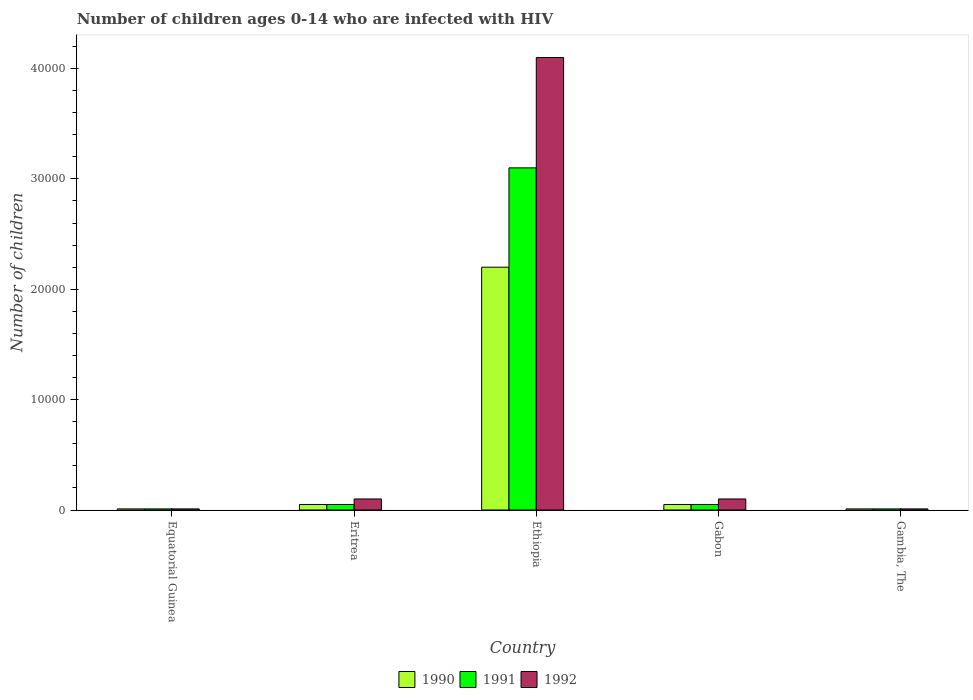How many different coloured bars are there?
Provide a short and direct response. 3. How many bars are there on the 5th tick from the left?
Your answer should be very brief. 3. What is the label of the 2nd group of bars from the left?
Offer a very short reply. Eritrea. In how many cases, is the number of bars for a given country not equal to the number of legend labels?
Keep it short and to the point. 0. What is the number of HIV infected children in 1990 in Ethiopia?
Your answer should be very brief. 2.20e+04. Across all countries, what is the maximum number of HIV infected children in 1990?
Provide a succinct answer. 2.20e+04. Across all countries, what is the minimum number of HIV infected children in 1991?
Give a very brief answer. 100. In which country was the number of HIV infected children in 1991 maximum?
Provide a short and direct response. Ethiopia. In which country was the number of HIV infected children in 1992 minimum?
Your response must be concise. Equatorial Guinea. What is the total number of HIV infected children in 1992 in the graph?
Make the answer very short. 4.32e+04. What is the difference between the number of HIV infected children in 1992 in Equatorial Guinea and that in Ethiopia?
Keep it short and to the point. -4.09e+04. What is the difference between the number of HIV infected children in 1992 in Ethiopia and the number of HIV infected children in 1990 in Gambia, The?
Your response must be concise. 4.09e+04. What is the average number of HIV infected children in 1990 per country?
Your response must be concise. 4640. What is the difference between the number of HIV infected children of/in 1991 and number of HIV infected children of/in 1992 in Eritrea?
Offer a terse response. -500. What is the ratio of the number of HIV infected children in 1990 in Equatorial Guinea to that in Gabon?
Offer a very short reply. 0.2. Is the number of HIV infected children in 1992 in Equatorial Guinea less than that in Eritrea?
Ensure brevity in your answer.  Yes. What is the difference between the highest and the second highest number of HIV infected children in 1991?
Offer a very short reply. 3.05e+04. What is the difference between the highest and the lowest number of HIV infected children in 1990?
Keep it short and to the point. 2.19e+04. What does the 3rd bar from the left in Equatorial Guinea represents?
Offer a very short reply. 1992. What does the 2nd bar from the right in Equatorial Guinea represents?
Provide a succinct answer. 1991. Is it the case that in every country, the sum of the number of HIV infected children in 1991 and number of HIV infected children in 1992 is greater than the number of HIV infected children in 1990?
Make the answer very short. Yes. What is the difference between two consecutive major ticks on the Y-axis?
Provide a succinct answer. 10000. Does the graph contain any zero values?
Give a very brief answer. No. How many legend labels are there?
Keep it short and to the point. 3. How are the legend labels stacked?
Make the answer very short. Horizontal. What is the title of the graph?
Your answer should be very brief. Number of children ages 0-14 who are infected with HIV. Does "1986" appear as one of the legend labels in the graph?
Your answer should be very brief. No. What is the label or title of the X-axis?
Offer a terse response. Country. What is the label or title of the Y-axis?
Your response must be concise. Number of children. What is the Number of children in 1991 in Eritrea?
Your answer should be compact. 500. What is the Number of children of 1990 in Ethiopia?
Provide a short and direct response. 2.20e+04. What is the Number of children of 1991 in Ethiopia?
Ensure brevity in your answer.  3.10e+04. What is the Number of children in 1992 in Ethiopia?
Offer a terse response. 4.10e+04. What is the Number of children in 1992 in Gabon?
Give a very brief answer. 1000. What is the Number of children of 1990 in Gambia, The?
Make the answer very short. 100. What is the Number of children of 1991 in Gambia, The?
Offer a very short reply. 100. What is the Number of children in 1992 in Gambia, The?
Offer a terse response. 100. Across all countries, what is the maximum Number of children of 1990?
Keep it short and to the point. 2.20e+04. Across all countries, what is the maximum Number of children of 1991?
Offer a terse response. 3.10e+04. Across all countries, what is the maximum Number of children in 1992?
Keep it short and to the point. 4.10e+04. Across all countries, what is the minimum Number of children of 1990?
Ensure brevity in your answer.  100. What is the total Number of children in 1990 in the graph?
Provide a succinct answer. 2.32e+04. What is the total Number of children of 1991 in the graph?
Offer a very short reply. 3.22e+04. What is the total Number of children in 1992 in the graph?
Keep it short and to the point. 4.32e+04. What is the difference between the Number of children of 1990 in Equatorial Guinea and that in Eritrea?
Ensure brevity in your answer.  -400. What is the difference between the Number of children in 1991 in Equatorial Guinea and that in Eritrea?
Give a very brief answer. -400. What is the difference between the Number of children in 1992 in Equatorial Guinea and that in Eritrea?
Your answer should be compact. -900. What is the difference between the Number of children in 1990 in Equatorial Guinea and that in Ethiopia?
Provide a succinct answer. -2.19e+04. What is the difference between the Number of children in 1991 in Equatorial Guinea and that in Ethiopia?
Make the answer very short. -3.09e+04. What is the difference between the Number of children of 1992 in Equatorial Guinea and that in Ethiopia?
Make the answer very short. -4.09e+04. What is the difference between the Number of children in 1990 in Equatorial Guinea and that in Gabon?
Offer a terse response. -400. What is the difference between the Number of children in 1991 in Equatorial Guinea and that in Gabon?
Provide a short and direct response. -400. What is the difference between the Number of children of 1992 in Equatorial Guinea and that in Gabon?
Make the answer very short. -900. What is the difference between the Number of children of 1990 in Equatorial Guinea and that in Gambia, The?
Your response must be concise. 0. What is the difference between the Number of children in 1991 in Equatorial Guinea and that in Gambia, The?
Make the answer very short. 0. What is the difference between the Number of children in 1992 in Equatorial Guinea and that in Gambia, The?
Provide a succinct answer. 0. What is the difference between the Number of children of 1990 in Eritrea and that in Ethiopia?
Give a very brief answer. -2.15e+04. What is the difference between the Number of children in 1991 in Eritrea and that in Ethiopia?
Provide a succinct answer. -3.05e+04. What is the difference between the Number of children of 1990 in Eritrea and that in Gambia, The?
Give a very brief answer. 400. What is the difference between the Number of children in 1992 in Eritrea and that in Gambia, The?
Ensure brevity in your answer.  900. What is the difference between the Number of children of 1990 in Ethiopia and that in Gabon?
Provide a short and direct response. 2.15e+04. What is the difference between the Number of children in 1991 in Ethiopia and that in Gabon?
Provide a short and direct response. 3.05e+04. What is the difference between the Number of children in 1992 in Ethiopia and that in Gabon?
Keep it short and to the point. 4.00e+04. What is the difference between the Number of children in 1990 in Ethiopia and that in Gambia, The?
Give a very brief answer. 2.19e+04. What is the difference between the Number of children of 1991 in Ethiopia and that in Gambia, The?
Offer a terse response. 3.09e+04. What is the difference between the Number of children in 1992 in Ethiopia and that in Gambia, The?
Keep it short and to the point. 4.09e+04. What is the difference between the Number of children of 1992 in Gabon and that in Gambia, The?
Ensure brevity in your answer.  900. What is the difference between the Number of children in 1990 in Equatorial Guinea and the Number of children in 1991 in Eritrea?
Offer a terse response. -400. What is the difference between the Number of children in 1990 in Equatorial Guinea and the Number of children in 1992 in Eritrea?
Offer a very short reply. -900. What is the difference between the Number of children in 1991 in Equatorial Guinea and the Number of children in 1992 in Eritrea?
Your answer should be very brief. -900. What is the difference between the Number of children in 1990 in Equatorial Guinea and the Number of children in 1991 in Ethiopia?
Your response must be concise. -3.09e+04. What is the difference between the Number of children in 1990 in Equatorial Guinea and the Number of children in 1992 in Ethiopia?
Keep it short and to the point. -4.09e+04. What is the difference between the Number of children in 1991 in Equatorial Guinea and the Number of children in 1992 in Ethiopia?
Your answer should be compact. -4.09e+04. What is the difference between the Number of children of 1990 in Equatorial Guinea and the Number of children of 1991 in Gabon?
Give a very brief answer. -400. What is the difference between the Number of children in 1990 in Equatorial Guinea and the Number of children in 1992 in Gabon?
Provide a short and direct response. -900. What is the difference between the Number of children of 1991 in Equatorial Guinea and the Number of children of 1992 in Gabon?
Your response must be concise. -900. What is the difference between the Number of children in 1990 in Equatorial Guinea and the Number of children in 1992 in Gambia, The?
Your response must be concise. 0. What is the difference between the Number of children of 1991 in Equatorial Guinea and the Number of children of 1992 in Gambia, The?
Make the answer very short. 0. What is the difference between the Number of children in 1990 in Eritrea and the Number of children in 1991 in Ethiopia?
Offer a terse response. -3.05e+04. What is the difference between the Number of children in 1990 in Eritrea and the Number of children in 1992 in Ethiopia?
Your response must be concise. -4.05e+04. What is the difference between the Number of children of 1991 in Eritrea and the Number of children of 1992 in Ethiopia?
Make the answer very short. -4.05e+04. What is the difference between the Number of children of 1990 in Eritrea and the Number of children of 1991 in Gabon?
Give a very brief answer. 0. What is the difference between the Number of children of 1990 in Eritrea and the Number of children of 1992 in Gabon?
Make the answer very short. -500. What is the difference between the Number of children of 1991 in Eritrea and the Number of children of 1992 in Gabon?
Offer a terse response. -500. What is the difference between the Number of children in 1990 in Eritrea and the Number of children in 1992 in Gambia, The?
Provide a short and direct response. 400. What is the difference between the Number of children of 1990 in Ethiopia and the Number of children of 1991 in Gabon?
Your response must be concise. 2.15e+04. What is the difference between the Number of children in 1990 in Ethiopia and the Number of children in 1992 in Gabon?
Make the answer very short. 2.10e+04. What is the difference between the Number of children of 1990 in Ethiopia and the Number of children of 1991 in Gambia, The?
Provide a short and direct response. 2.19e+04. What is the difference between the Number of children of 1990 in Ethiopia and the Number of children of 1992 in Gambia, The?
Give a very brief answer. 2.19e+04. What is the difference between the Number of children of 1991 in Ethiopia and the Number of children of 1992 in Gambia, The?
Offer a very short reply. 3.09e+04. What is the difference between the Number of children of 1990 in Gabon and the Number of children of 1991 in Gambia, The?
Offer a very short reply. 400. What is the difference between the Number of children in 1990 in Gabon and the Number of children in 1992 in Gambia, The?
Your answer should be very brief. 400. What is the average Number of children of 1990 per country?
Provide a succinct answer. 4640. What is the average Number of children of 1991 per country?
Offer a very short reply. 6440. What is the average Number of children in 1992 per country?
Offer a terse response. 8640. What is the difference between the Number of children of 1990 and Number of children of 1991 in Equatorial Guinea?
Your answer should be compact. 0. What is the difference between the Number of children of 1990 and Number of children of 1992 in Eritrea?
Provide a succinct answer. -500. What is the difference between the Number of children in 1991 and Number of children in 1992 in Eritrea?
Give a very brief answer. -500. What is the difference between the Number of children in 1990 and Number of children in 1991 in Ethiopia?
Your answer should be compact. -9000. What is the difference between the Number of children in 1990 and Number of children in 1992 in Ethiopia?
Give a very brief answer. -1.90e+04. What is the difference between the Number of children of 1991 and Number of children of 1992 in Ethiopia?
Offer a terse response. -10000. What is the difference between the Number of children in 1990 and Number of children in 1992 in Gabon?
Offer a terse response. -500. What is the difference between the Number of children of 1991 and Number of children of 1992 in Gabon?
Provide a short and direct response. -500. What is the ratio of the Number of children of 1990 in Equatorial Guinea to that in Eritrea?
Make the answer very short. 0.2. What is the ratio of the Number of children of 1992 in Equatorial Guinea to that in Eritrea?
Your response must be concise. 0.1. What is the ratio of the Number of children in 1990 in Equatorial Guinea to that in Ethiopia?
Offer a very short reply. 0. What is the ratio of the Number of children of 1991 in Equatorial Guinea to that in Ethiopia?
Make the answer very short. 0. What is the ratio of the Number of children in 1992 in Equatorial Guinea to that in Ethiopia?
Make the answer very short. 0. What is the ratio of the Number of children of 1990 in Equatorial Guinea to that in Gabon?
Provide a succinct answer. 0.2. What is the ratio of the Number of children in 1992 in Equatorial Guinea to that in Gambia, The?
Offer a very short reply. 1. What is the ratio of the Number of children in 1990 in Eritrea to that in Ethiopia?
Give a very brief answer. 0.02. What is the ratio of the Number of children of 1991 in Eritrea to that in Ethiopia?
Offer a terse response. 0.02. What is the ratio of the Number of children in 1992 in Eritrea to that in Ethiopia?
Your response must be concise. 0.02. What is the ratio of the Number of children in 1990 in Eritrea to that in Gabon?
Your answer should be very brief. 1. What is the ratio of the Number of children of 1992 in Eritrea to that in Gabon?
Offer a terse response. 1. What is the ratio of the Number of children in 1990 in Ethiopia to that in Gabon?
Make the answer very short. 44. What is the ratio of the Number of children of 1991 in Ethiopia to that in Gabon?
Keep it short and to the point. 62. What is the ratio of the Number of children of 1992 in Ethiopia to that in Gabon?
Ensure brevity in your answer.  41. What is the ratio of the Number of children in 1990 in Ethiopia to that in Gambia, The?
Your answer should be compact. 220. What is the ratio of the Number of children of 1991 in Ethiopia to that in Gambia, The?
Provide a short and direct response. 310. What is the ratio of the Number of children of 1992 in Ethiopia to that in Gambia, The?
Your answer should be compact. 410. What is the difference between the highest and the second highest Number of children in 1990?
Provide a succinct answer. 2.15e+04. What is the difference between the highest and the second highest Number of children of 1991?
Make the answer very short. 3.05e+04. What is the difference between the highest and the second highest Number of children of 1992?
Offer a terse response. 4.00e+04. What is the difference between the highest and the lowest Number of children of 1990?
Your answer should be very brief. 2.19e+04. What is the difference between the highest and the lowest Number of children of 1991?
Give a very brief answer. 3.09e+04. What is the difference between the highest and the lowest Number of children in 1992?
Provide a short and direct response. 4.09e+04. 